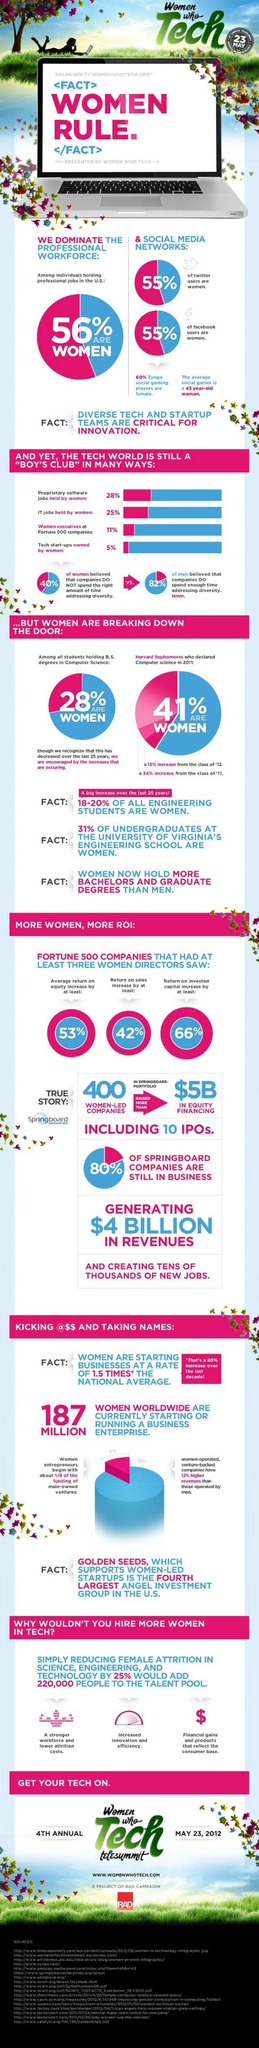Outline some significant characteristics in this image. Approximately 72% of proprietary software jobs in the United States were held by men in a given year. A recent study found that 89% of executive positions at Fortune 500 companies are held by men. Approximately 44% of the professional workforce in the United States is comprised of men. According to a recent survey, 45% of Facebook users in the United States are men. In a study of tech start-ups, it was found that a staggering 95% were owned by men. 